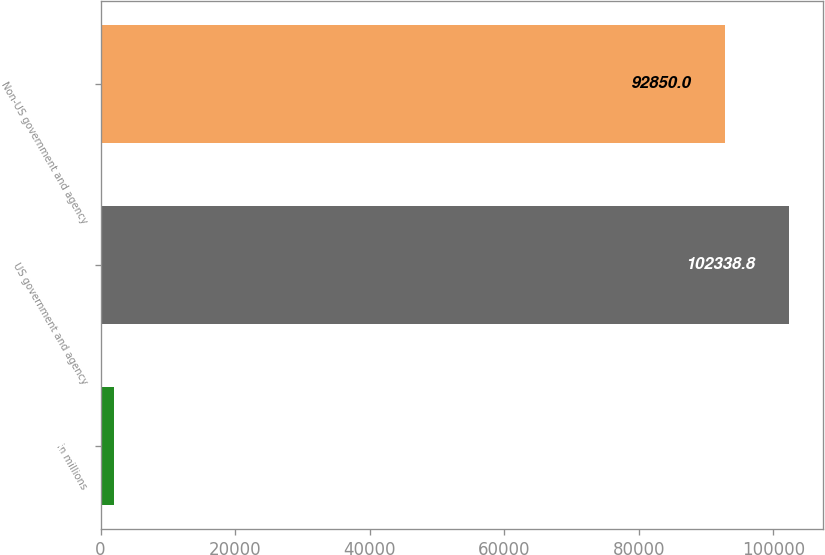<chart> <loc_0><loc_0><loc_500><loc_500><bar_chart><fcel>in millions<fcel>US government and agency<fcel>Non-US government and agency<nl><fcel>2017<fcel>102339<fcel>92850<nl></chart> 